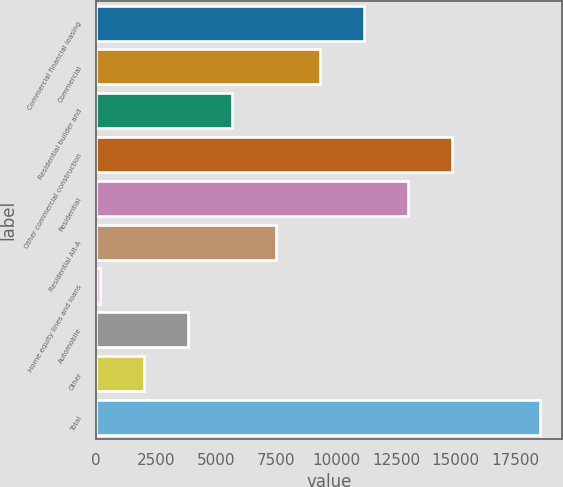Convert chart. <chart><loc_0><loc_0><loc_500><loc_500><bar_chart><fcel>Commercial financial leasing<fcel>Commercial<fcel>Residential builder and<fcel>Other commercial construction<fcel>Residential<fcel>Residential Alt-A<fcel>Home equity lines and loans<fcel>Automobile<fcel>Other<fcel>Total<nl><fcel>11183.6<fcel>9349.5<fcel>5681.3<fcel>14851.8<fcel>13017.7<fcel>7515.4<fcel>179<fcel>3847.2<fcel>2013.1<fcel>18520<nl></chart> 